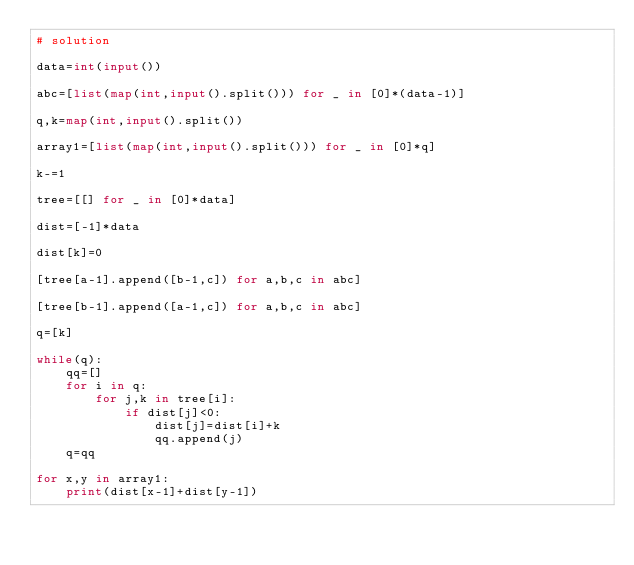Convert code to text. <code><loc_0><loc_0><loc_500><loc_500><_Python_># solution

data=int(input())

abc=[list(map(int,input().split())) for _ in [0]*(data-1)]

q,k=map(int,input().split())

array1=[list(map(int,input().split())) for _ in [0]*q]

k-=1

tree=[[] for _ in [0]*data]

dist=[-1]*data

dist[k]=0

[tree[a-1].append([b-1,c]) for a,b,c in abc]

[tree[b-1].append([a-1,c]) for a,b,c in abc]

q=[k]

while(q):
	qq=[]
	for i in q:
		for j,k in tree[i]:
			if dist[j]<0:
				dist[j]=dist[i]+k
				qq.append(j)
	q=qq

for x,y in array1:
	print(dist[x-1]+dist[y-1])</code> 